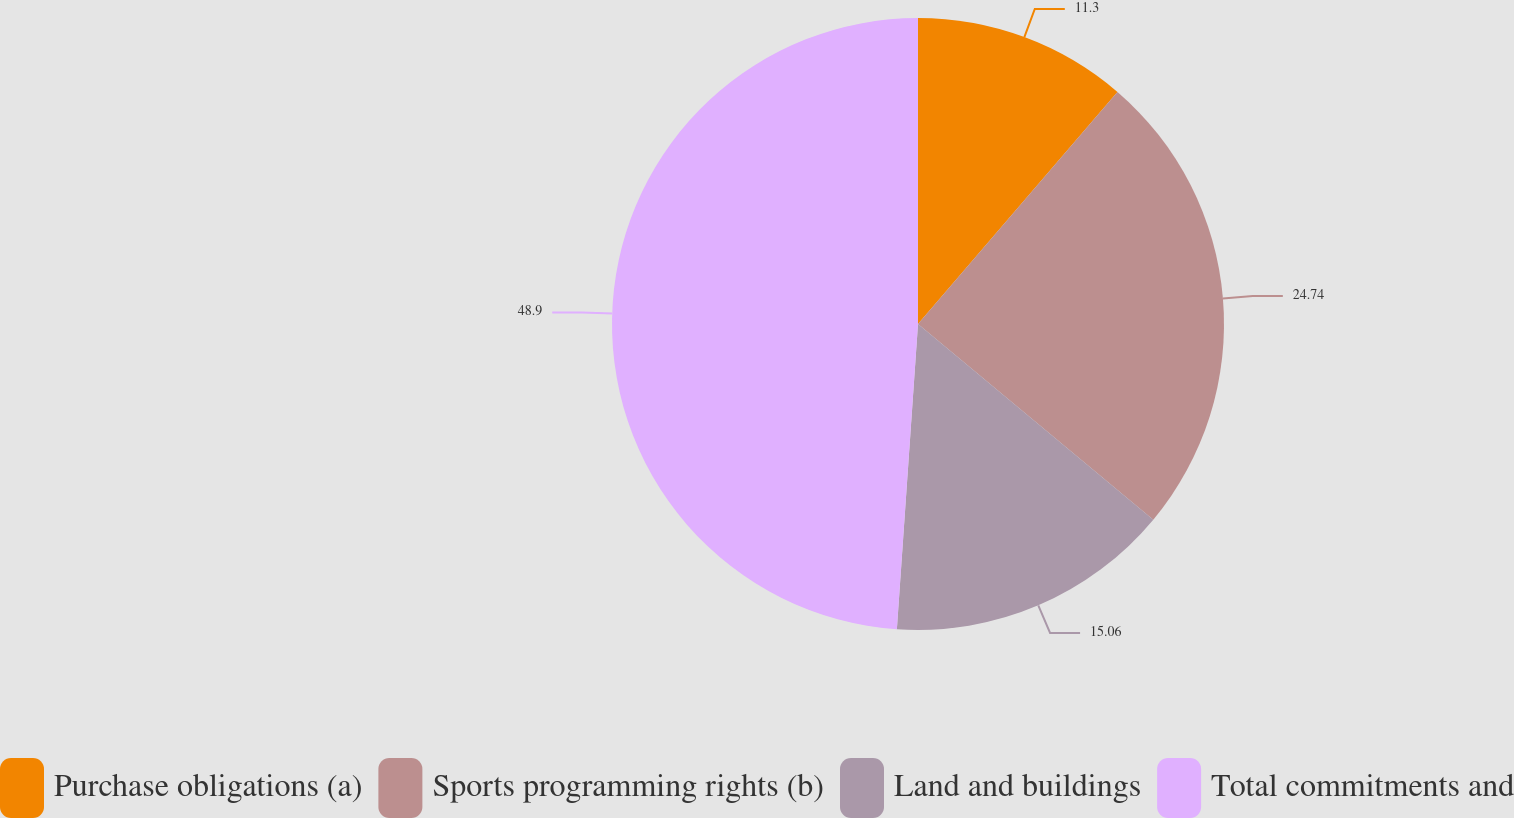Convert chart to OTSL. <chart><loc_0><loc_0><loc_500><loc_500><pie_chart><fcel>Purchase obligations (a)<fcel>Sports programming rights (b)<fcel>Land and buildings<fcel>Total commitments and<nl><fcel>11.3%<fcel>24.74%<fcel>15.06%<fcel>48.9%<nl></chart> 